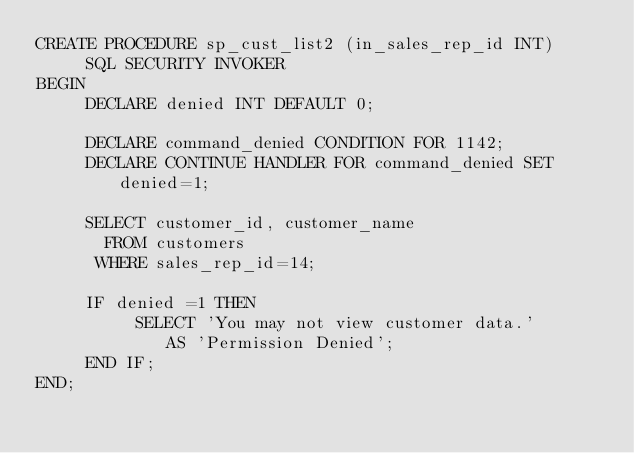<code> <loc_0><loc_0><loc_500><loc_500><_SQL_>CREATE PROCEDURE sp_cust_list2 (in_sales_rep_id INT)
	 SQL SECURITY INVOKER
BEGIN
	 DECLARE denied INT DEFAULT 0;
	
	 DECLARE command_denied CONDITION FOR 1142;
	 DECLARE CONTINUE HANDLER FOR command_denied SET denied=1;
	
	 SELECT customer_id, customer_name	
	   FROM customers
	  WHERE sales_rep_id=14;
	
	 IF denied =1 THEN 
		  SELECT 'You may not view customer data.'
			 AS 'Permission Denied';
	 END IF;
END;
</code> 